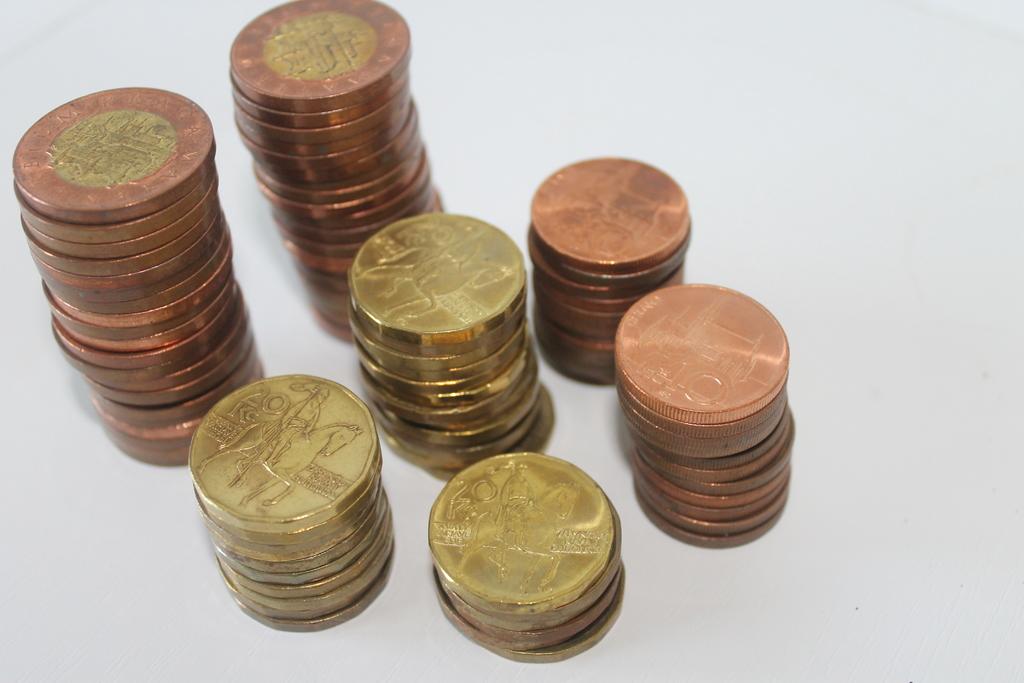What number is on the bottom stack of coins?
Make the answer very short. 20. 